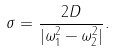Convert formula to latex. <formula><loc_0><loc_0><loc_500><loc_500>\sigma = \frac { 2 D } { | \omega _ { 1 } ^ { 2 } - \omega _ { 2 } ^ { 2 } | } .</formula> 